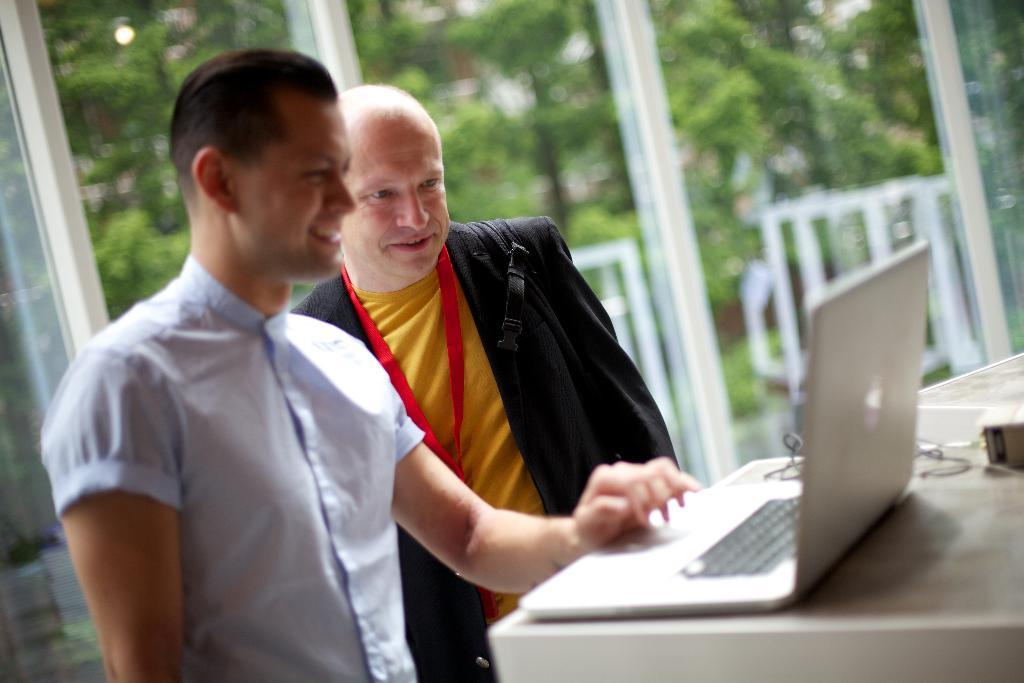How many people are in the image? There are two men in the image. What are the men doing in the image? Both men are standing and smiling. What is present on the table in the image? There is a laptop on the table. Is there any furniture in the image besides the table? The facts provided do not mention any other furniture. Where is the throne located in the image? There is no throne present in the image. What type of market can be seen in the background of the image? There is no market visible in the image. 